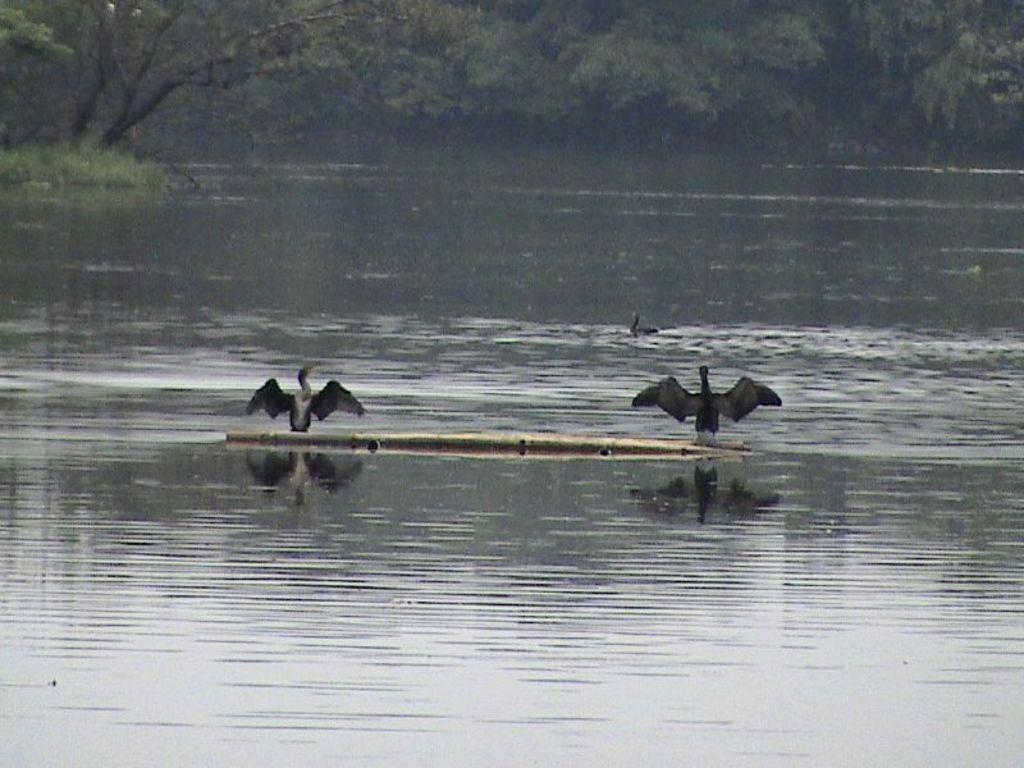What is the main element in the image? There is water in the image. What object can be seen in the center of the image? There is an object that looks like a stick in the center of the image. How many birds are visible in the image? There are 3 birds in the image. What can be seen in the background of the image? There are trees and grass in the background of the image. What type of cork can be seen floating on the water in the image? There is no cork present in the image; it only features water, a stick-like object, birds, trees, and grass. 